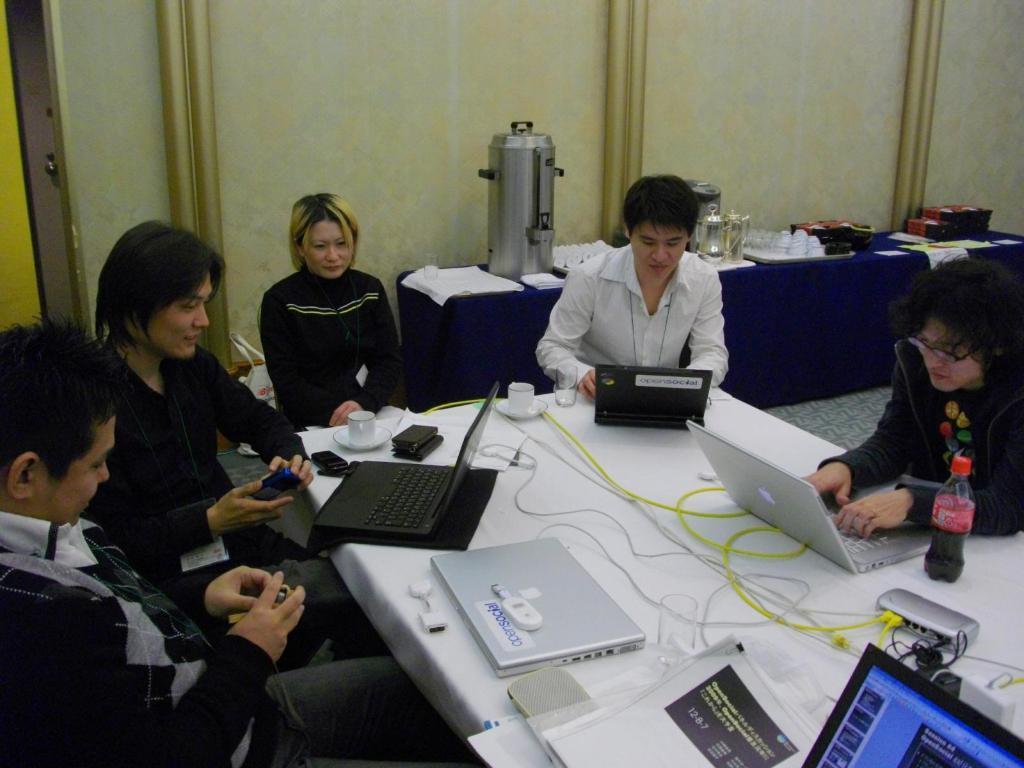Can you describe this image briefly? In this image there are group of people who are sitting around the table, and in front of them there is a table. On the table there are some laptops, files, wires, mobiles, cups, saucers, glass and some objects. And in background there is a table, on the table there are some plates, cups, box and some objects. And in the background there is a wall. 